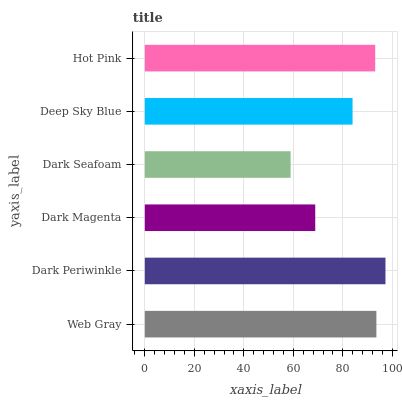Is Dark Seafoam the minimum?
Answer yes or no. Yes. Is Dark Periwinkle the maximum?
Answer yes or no. Yes. Is Dark Magenta the minimum?
Answer yes or no. No. Is Dark Magenta the maximum?
Answer yes or no. No. Is Dark Periwinkle greater than Dark Magenta?
Answer yes or no. Yes. Is Dark Magenta less than Dark Periwinkle?
Answer yes or no. Yes. Is Dark Magenta greater than Dark Periwinkle?
Answer yes or no. No. Is Dark Periwinkle less than Dark Magenta?
Answer yes or no. No. Is Hot Pink the high median?
Answer yes or no. Yes. Is Deep Sky Blue the low median?
Answer yes or no. Yes. Is Web Gray the high median?
Answer yes or no. No. Is Dark Seafoam the low median?
Answer yes or no. No. 